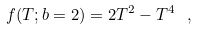<formula> <loc_0><loc_0><loc_500><loc_500>f ( T ; b = 2 ) = 2 T ^ { 2 } - T ^ { 4 } \ ,</formula> 